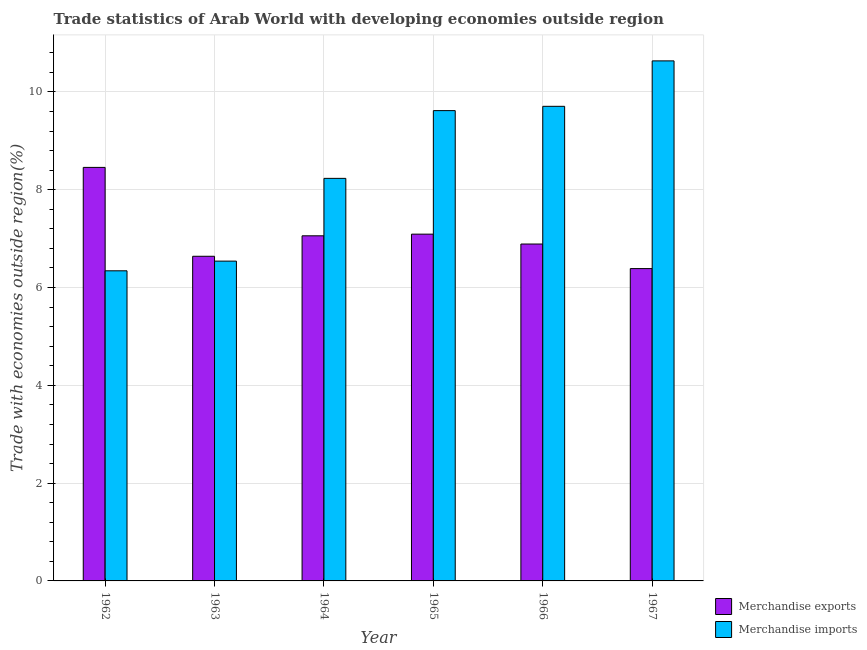How many different coloured bars are there?
Your answer should be compact. 2. How many groups of bars are there?
Give a very brief answer. 6. Are the number of bars per tick equal to the number of legend labels?
Offer a very short reply. Yes. How many bars are there on the 6th tick from the left?
Make the answer very short. 2. How many bars are there on the 2nd tick from the right?
Make the answer very short. 2. What is the merchandise imports in 1967?
Your response must be concise. 10.64. Across all years, what is the maximum merchandise exports?
Make the answer very short. 8.46. Across all years, what is the minimum merchandise exports?
Offer a very short reply. 6.39. In which year was the merchandise imports maximum?
Make the answer very short. 1967. What is the total merchandise exports in the graph?
Offer a very short reply. 42.52. What is the difference between the merchandise exports in 1966 and that in 1967?
Ensure brevity in your answer.  0.5. What is the difference between the merchandise imports in 1962 and the merchandise exports in 1964?
Offer a very short reply. -1.89. What is the average merchandise exports per year?
Offer a terse response. 7.09. In how many years, is the merchandise exports greater than 4 %?
Make the answer very short. 6. What is the ratio of the merchandise imports in 1964 to that in 1966?
Your answer should be compact. 0.85. Is the difference between the merchandise imports in 1965 and 1966 greater than the difference between the merchandise exports in 1965 and 1966?
Your answer should be compact. No. What is the difference between the highest and the second highest merchandise exports?
Offer a very short reply. 1.37. What is the difference between the highest and the lowest merchandise imports?
Keep it short and to the point. 4.29. Are all the bars in the graph horizontal?
Offer a terse response. No. Are the values on the major ticks of Y-axis written in scientific E-notation?
Your response must be concise. No. Does the graph contain any zero values?
Offer a terse response. No. Does the graph contain grids?
Make the answer very short. Yes. Where does the legend appear in the graph?
Make the answer very short. Bottom right. How many legend labels are there?
Keep it short and to the point. 2. What is the title of the graph?
Provide a succinct answer. Trade statistics of Arab World with developing economies outside region. Does "Rural" appear as one of the legend labels in the graph?
Ensure brevity in your answer.  No. What is the label or title of the Y-axis?
Offer a very short reply. Trade with economies outside region(%). What is the Trade with economies outside region(%) of Merchandise exports in 1962?
Your response must be concise. 8.46. What is the Trade with economies outside region(%) of Merchandise imports in 1962?
Provide a succinct answer. 6.34. What is the Trade with economies outside region(%) of Merchandise exports in 1963?
Give a very brief answer. 6.64. What is the Trade with economies outside region(%) of Merchandise imports in 1963?
Make the answer very short. 6.54. What is the Trade with economies outside region(%) in Merchandise exports in 1964?
Make the answer very short. 7.06. What is the Trade with economies outside region(%) of Merchandise imports in 1964?
Ensure brevity in your answer.  8.23. What is the Trade with economies outside region(%) in Merchandise exports in 1965?
Offer a terse response. 7.09. What is the Trade with economies outside region(%) in Merchandise imports in 1965?
Your answer should be very brief. 9.62. What is the Trade with economies outside region(%) of Merchandise exports in 1966?
Keep it short and to the point. 6.89. What is the Trade with economies outside region(%) of Merchandise imports in 1966?
Give a very brief answer. 9.71. What is the Trade with economies outside region(%) of Merchandise exports in 1967?
Keep it short and to the point. 6.39. What is the Trade with economies outside region(%) in Merchandise imports in 1967?
Your response must be concise. 10.64. Across all years, what is the maximum Trade with economies outside region(%) of Merchandise exports?
Offer a terse response. 8.46. Across all years, what is the maximum Trade with economies outside region(%) in Merchandise imports?
Your answer should be compact. 10.64. Across all years, what is the minimum Trade with economies outside region(%) in Merchandise exports?
Your response must be concise. 6.39. Across all years, what is the minimum Trade with economies outside region(%) in Merchandise imports?
Offer a terse response. 6.34. What is the total Trade with economies outside region(%) in Merchandise exports in the graph?
Provide a short and direct response. 42.52. What is the total Trade with economies outside region(%) of Merchandise imports in the graph?
Give a very brief answer. 51.07. What is the difference between the Trade with economies outside region(%) in Merchandise exports in 1962 and that in 1963?
Make the answer very short. 1.82. What is the difference between the Trade with economies outside region(%) of Merchandise imports in 1962 and that in 1963?
Offer a very short reply. -0.2. What is the difference between the Trade with economies outside region(%) in Merchandise exports in 1962 and that in 1964?
Your answer should be very brief. 1.4. What is the difference between the Trade with economies outside region(%) of Merchandise imports in 1962 and that in 1964?
Keep it short and to the point. -1.89. What is the difference between the Trade with economies outside region(%) of Merchandise exports in 1962 and that in 1965?
Your answer should be compact. 1.37. What is the difference between the Trade with economies outside region(%) of Merchandise imports in 1962 and that in 1965?
Offer a terse response. -3.28. What is the difference between the Trade with economies outside region(%) in Merchandise exports in 1962 and that in 1966?
Offer a very short reply. 1.57. What is the difference between the Trade with economies outside region(%) of Merchandise imports in 1962 and that in 1966?
Your response must be concise. -3.36. What is the difference between the Trade with economies outside region(%) of Merchandise exports in 1962 and that in 1967?
Your response must be concise. 2.07. What is the difference between the Trade with economies outside region(%) in Merchandise imports in 1962 and that in 1967?
Make the answer very short. -4.29. What is the difference between the Trade with economies outside region(%) in Merchandise exports in 1963 and that in 1964?
Your answer should be compact. -0.42. What is the difference between the Trade with economies outside region(%) of Merchandise imports in 1963 and that in 1964?
Ensure brevity in your answer.  -1.69. What is the difference between the Trade with economies outside region(%) of Merchandise exports in 1963 and that in 1965?
Offer a very short reply. -0.45. What is the difference between the Trade with economies outside region(%) in Merchandise imports in 1963 and that in 1965?
Provide a succinct answer. -3.08. What is the difference between the Trade with economies outside region(%) in Merchandise exports in 1963 and that in 1966?
Your response must be concise. -0.25. What is the difference between the Trade with economies outside region(%) of Merchandise imports in 1963 and that in 1966?
Offer a terse response. -3.17. What is the difference between the Trade with economies outside region(%) in Merchandise exports in 1963 and that in 1967?
Your response must be concise. 0.25. What is the difference between the Trade with economies outside region(%) in Merchandise imports in 1963 and that in 1967?
Make the answer very short. -4.09. What is the difference between the Trade with economies outside region(%) of Merchandise exports in 1964 and that in 1965?
Your response must be concise. -0.03. What is the difference between the Trade with economies outside region(%) in Merchandise imports in 1964 and that in 1965?
Ensure brevity in your answer.  -1.39. What is the difference between the Trade with economies outside region(%) of Merchandise exports in 1964 and that in 1966?
Make the answer very short. 0.17. What is the difference between the Trade with economies outside region(%) of Merchandise imports in 1964 and that in 1966?
Give a very brief answer. -1.47. What is the difference between the Trade with economies outside region(%) in Merchandise exports in 1964 and that in 1967?
Your response must be concise. 0.67. What is the difference between the Trade with economies outside region(%) of Merchandise imports in 1964 and that in 1967?
Your answer should be compact. -2.4. What is the difference between the Trade with economies outside region(%) of Merchandise exports in 1965 and that in 1966?
Your response must be concise. 0.2. What is the difference between the Trade with economies outside region(%) of Merchandise imports in 1965 and that in 1966?
Provide a short and direct response. -0.09. What is the difference between the Trade with economies outside region(%) in Merchandise exports in 1965 and that in 1967?
Provide a short and direct response. 0.7. What is the difference between the Trade with economies outside region(%) of Merchandise imports in 1965 and that in 1967?
Keep it short and to the point. -1.02. What is the difference between the Trade with economies outside region(%) of Merchandise exports in 1966 and that in 1967?
Your answer should be very brief. 0.5. What is the difference between the Trade with economies outside region(%) of Merchandise imports in 1966 and that in 1967?
Provide a short and direct response. -0.93. What is the difference between the Trade with economies outside region(%) of Merchandise exports in 1962 and the Trade with economies outside region(%) of Merchandise imports in 1963?
Your answer should be very brief. 1.92. What is the difference between the Trade with economies outside region(%) in Merchandise exports in 1962 and the Trade with economies outside region(%) in Merchandise imports in 1964?
Offer a very short reply. 0.22. What is the difference between the Trade with economies outside region(%) in Merchandise exports in 1962 and the Trade with economies outside region(%) in Merchandise imports in 1965?
Make the answer very short. -1.16. What is the difference between the Trade with economies outside region(%) in Merchandise exports in 1962 and the Trade with economies outside region(%) in Merchandise imports in 1966?
Your answer should be compact. -1.25. What is the difference between the Trade with economies outside region(%) in Merchandise exports in 1962 and the Trade with economies outside region(%) in Merchandise imports in 1967?
Your answer should be very brief. -2.18. What is the difference between the Trade with economies outside region(%) in Merchandise exports in 1963 and the Trade with economies outside region(%) in Merchandise imports in 1964?
Offer a very short reply. -1.59. What is the difference between the Trade with economies outside region(%) of Merchandise exports in 1963 and the Trade with economies outside region(%) of Merchandise imports in 1965?
Provide a succinct answer. -2.98. What is the difference between the Trade with economies outside region(%) of Merchandise exports in 1963 and the Trade with economies outside region(%) of Merchandise imports in 1966?
Your answer should be very brief. -3.07. What is the difference between the Trade with economies outside region(%) in Merchandise exports in 1963 and the Trade with economies outside region(%) in Merchandise imports in 1967?
Provide a succinct answer. -4. What is the difference between the Trade with economies outside region(%) of Merchandise exports in 1964 and the Trade with economies outside region(%) of Merchandise imports in 1965?
Your response must be concise. -2.56. What is the difference between the Trade with economies outside region(%) of Merchandise exports in 1964 and the Trade with economies outside region(%) of Merchandise imports in 1966?
Offer a very short reply. -2.65. What is the difference between the Trade with economies outside region(%) of Merchandise exports in 1964 and the Trade with economies outside region(%) of Merchandise imports in 1967?
Give a very brief answer. -3.58. What is the difference between the Trade with economies outside region(%) in Merchandise exports in 1965 and the Trade with economies outside region(%) in Merchandise imports in 1966?
Offer a terse response. -2.61. What is the difference between the Trade with economies outside region(%) of Merchandise exports in 1965 and the Trade with economies outside region(%) of Merchandise imports in 1967?
Provide a succinct answer. -3.54. What is the difference between the Trade with economies outside region(%) in Merchandise exports in 1966 and the Trade with economies outside region(%) in Merchandise imports in 1967?
Ensure brevity in your answer.  -3.75. What is the average Trade with economies outside region(%) of Merchandise exports per year?
Offer a terse response. 7.09. What is the average Trade with economies outside region(%) in Merchandise imports per year?
Provide a succinct answer. 8.51. In the year 1962, what is the difference between the Trade with economies outside region(%) of Merchandise exports and Trade with economies outside region(%) of Merchandise imports?
Give a very brief answer. 2.11. In the year 1963, what is the difference between the Trade with economies outside region(%) of Merchandise exports and Trade with economies outside region(%) of Merchandise imports?
Ensure brevity in your answer.  0.1. In the year 1964, what is the difference between the Trade with economies outside region(%) in Merchandise exports and Trade with economies outside region(%) in Merchandise imports?
Provide a succinct answer. -1.17. In the year 1965, what is the difference between the Trade with economies outside region(%) of Merchandise exports and Trade with economies outside region(%) of Merchandise imports?
Offer a terse response. -2.53. In the year 1966, what is the difference between the Trade with economies outside region(%) of Merchandise exports and Trade with economies outside region(%) of Merchandise imports?
Your answer should be very brief. -2.82. In the year 1967, what is the difference between the Trade with economies outside region(%) of Merchandise exports and Trade with economies outside region(%) of Merchandise imports?
Your answer should be very brief. -4.25. What is the ratio of the Trade with economies outside region(%) of Merchandise exports in 1962 to that in 1963?
Provide a short and direct response. 1.27. What is the ratio of the Trade with economies outside region(%) in Merchandise imports in 1962 to that in 1963?
Your response must be concise. 0.97. What is the ratio of the Trade with economies outside region(%) of Merchandise exports in 1962 to that in 1964?
Your answer should be very brief. 1.2. What is the ratio of the Trade with economies outside region(%) in Merchandise imports in 1962 to that in 1964?
Your answer should be compact. 0.77. What is the ratio of the Trade with economies outside region(%) in Merchandise exports in 1962 to that in 1965?
Make the answer very short. 1.19. What is the ratio of the Trade with economies outside region(%) in Merchandise imports in 1962 to that in 1965?
Give a very brief answer. 0.66. What is the ratio of the Trade with economies outside region(%) of Merchandise exports in 1962 to that in 1966?
Your response must be concise. 1.23. What is the ratio of the Trade with economies outside region(%) of Merchandise imports in 1962 to that in 1966?
Your answer should be very brief. 0.65. What is the ratio of the Trade with economies outside region(%) of Merchandise exports in 1962 to that in 1967?
Keep it short and to the point. 1.32. What is the ratio of the Trade with economies outside region(%) of Merchandise imports in 1962 to that in 1967?
Offer a terse response. 0.6. What is the ratio of the Trade with economies outside region(%) of Merchandise exports in 1963 to that in 1964?
Your response must be concise. 0.94. What is the ratio of the Trade with economies outside region(%) of Merchandise imports in 1963 to that in 1964?
Provide a short and direct response. 0.79. What is the ratio of the Trade with economies outside region(%) in Merchandise exports in 1963 to that in 1965?
Your answer should be very brief. 0.94. What is the ratio of the Trade with economies outside region(%) in Merchandise imports in 1963 to that in 1965?
Give a very brief answer. 0.68. What is the ratio of the Trade with economies outside region(%) of Merchandise exports in 1963 to that in 1966?
Offer a terse response. 0.96. What is the ratio of the Trade with economies outside region(%) of Merchandise imports in 1963 to that in 1966?
Your response must be concise. 0.67. What is the ratio of the Trade with economies outside region(%) in Merchandise exports in 1963 to that in 1967?
Your answer should be very brief. 1.04. What is the ratio of the Trade with economies outside region(%) of Merchandise imports in 1963 to that in 1967?
Make the answer very short. 0.61. What is the ratio of the Trade with economies outside region(%) of Merchandise imports in 1964 to that in 1965?
Provide a succinct answer. 0.86. What is the ratio of the Trade with economies outside region(%) of Merchandise exports in 1964 to that in 1966?
Make the answer very short. 1.02. What is the ratio of the Trade with economies outside region(%) of Merchandise imports in 1964 to that in 1966?
Your answer should be compact. 0.85. What is the ratio of the Trade with economies outside region(%) of Merchandise exports in 1964 to that in 1967?
Ensure brevity in your answer.  1.1. What is the ratio of the Trade with economies outside region(%) in Merchandise imports in 1964 to that in 1967?
Offer a terse response. 0.77. What is the ratio of the Trade with economies outside region(%) of Merchandise exports in 1965 to that in 1966?
Your answer should be very brief. 1.03. What is the ratio of the Trade with economies outside region(%) in Merchandise imports in 1965 to that in 1966?
Provide a succinct answer. 0.99. What is the ratio of the Trade with economies outside region(%) of Merchandise exports in 1965 to that in 1967?
Give a very brief answer. 1.11. What is the ratio of the Trade with economies outside region(%) of Merchandise imports in 1965 to that in 1967?
Ensure brevity in your answer.  0.9. What is the ratio of the Trade with economies outside region(%) in Merchandise exports in 1966 to that in 1967?
Provide a short and direct response. 1.08. What is the ratio of the Trade with economies outside region(%) in Merchandise imports in 1966 to that in 1967?
Your response must be concise. 0.91. What is the difference between the highest and the second highest Trade with economies outside region(%) in Merchandise exports?
Offer a very short reply. 1.37. What is the difference between the highest and the second highest Trade with economies outside region(%) in Merchandise imports?
Provide a succinct answer. 0.93. What is the difference between the highest and the lowest Trade with economies outside region(%) in Merchandise exports?
Provide a short and direct response. 2.07. What is the difference between the highest and the lowest Trade with economies outside region(%) in Merchandise imports?
Your response must be concise. 4.29. 